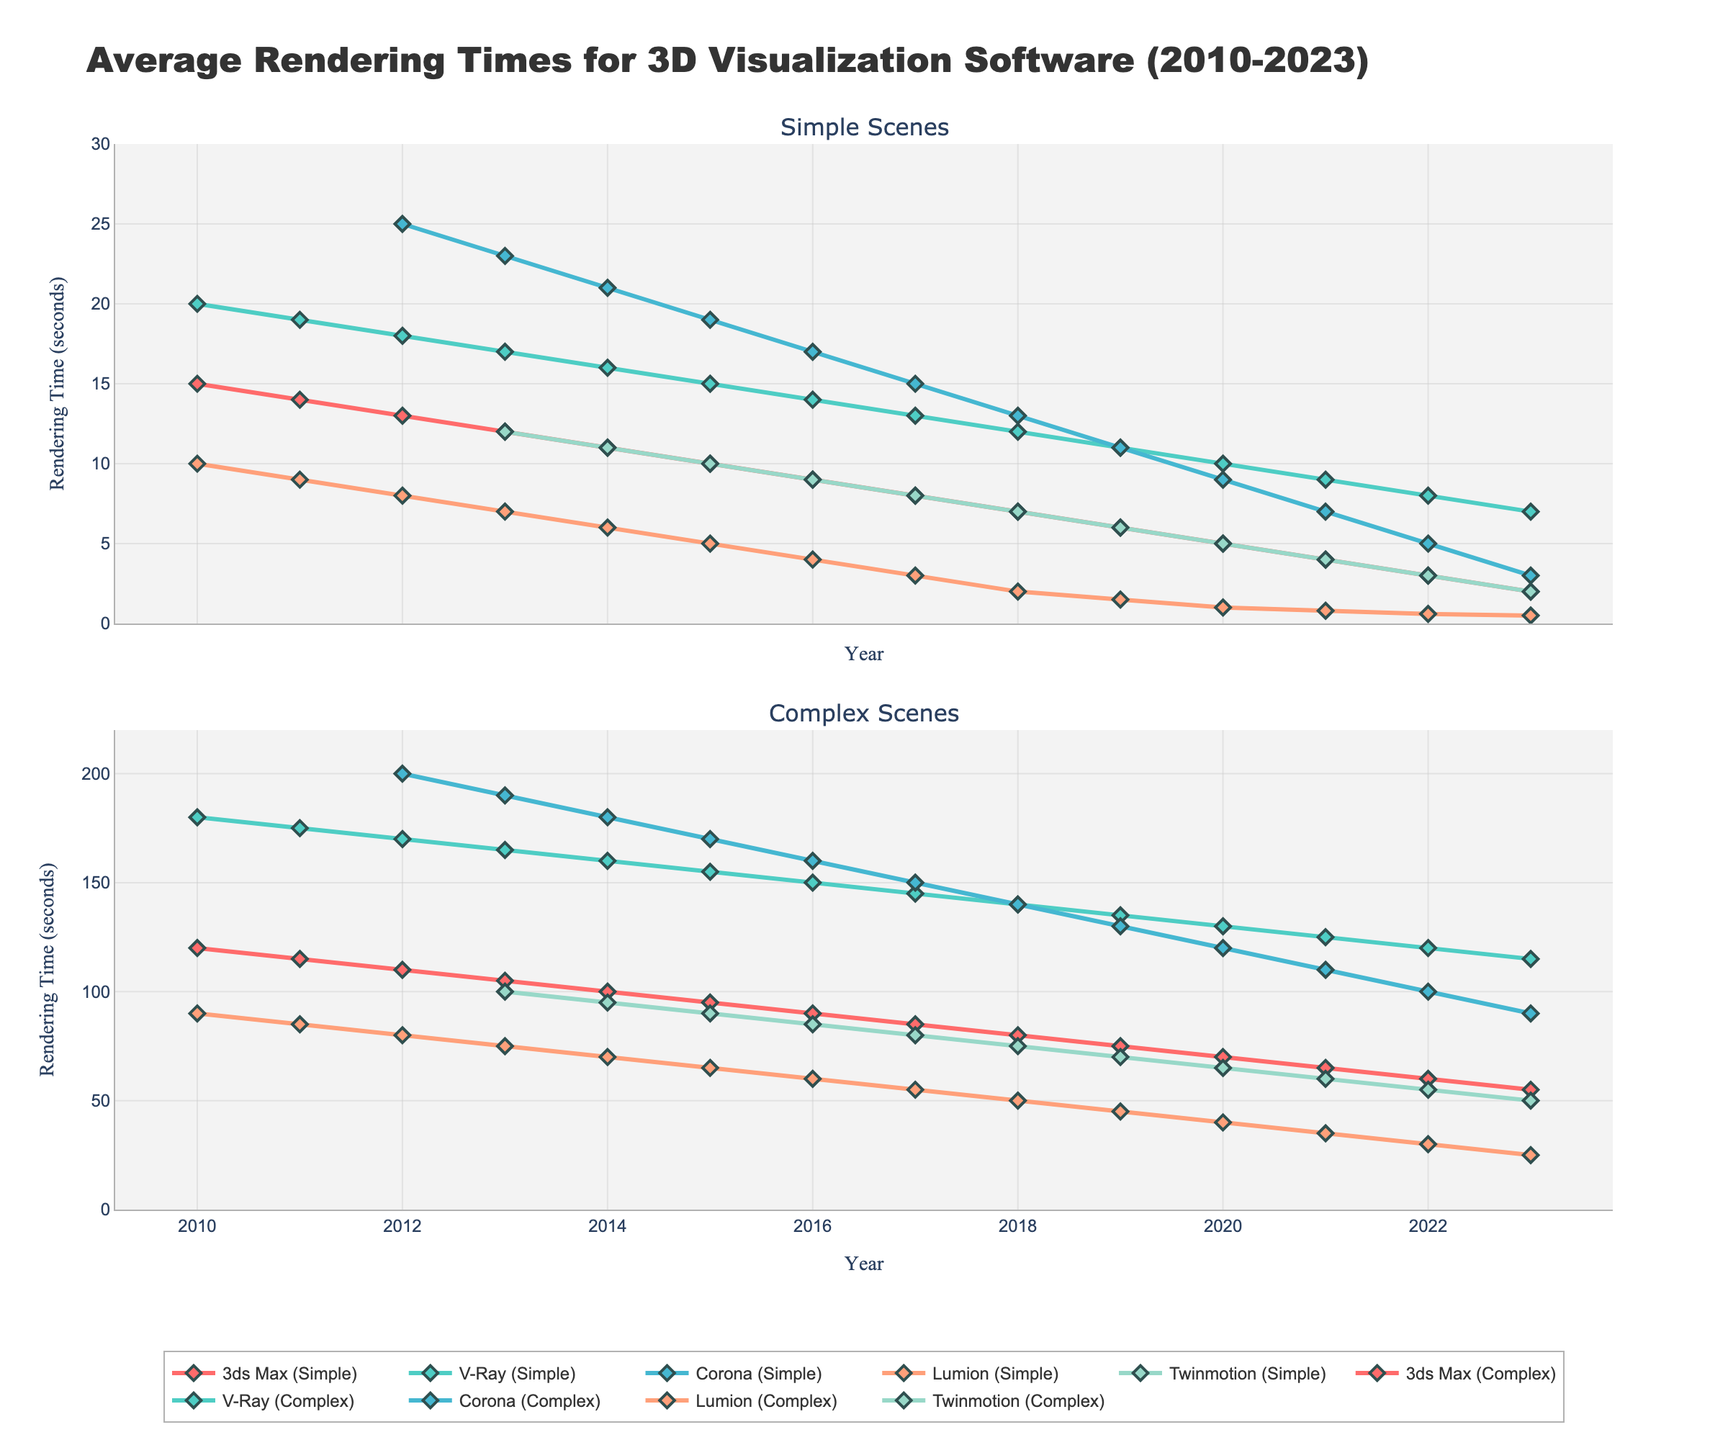Which software had the fastest rendering time for simple scenes in 2023? First, observe the line corresponding to the "Simple Scenes" subplot for 2023. Identify which software line reaches the lowest point on the y-axis. The "Twinmotion (Simple)" line reaches the lowest value at 2 seconds in 2023.
Answer: Twinmotion How has the rendering time of V-Ray for complex scenes changed from 2010 to 2023? Track the line labeled "V-Ray (Complex)" from 2010 to 2023 in the "Complex Scenes" subplot. The rendering time decreased from 180 seconds in 2010 to 115 seconds in 2023, showing a consistent downward trend.
Answer: Decreased by 65 seconds Which software showed the most improvement in rendering time for simple scenes between 2013 and 2018? Compare the time differences for each software in the "Simple Scenes" subplot between 2013 and 2018. Compute the decrease for each line. "Lumion (Simple)" decreased from 7 seconds to 2 seconds, showing an improvement of 5 seconds, which is the most significant.
Answer: Lumion What was the difference in rendering time between 3ds Max (Simple) and Corona (Complex) in 2020? Find the points for 3ds Max (Simple) and Corona (Complex) on the y-axis for the year 2020. 3ds Max (Simple) is at 5 seconds, and Corona (Complex) is at 120 seconds. Subtract the lower value from the higher value: 120 - 5.
Answer: 115 seconds For which complexity (simple or complex) do all software show a greater decrease in rendering time over the given years? Compare the trend lines in both subplots for all software from 2010 to 2023. In the "Complex Scenes" subplot, the initial and final values are generally higher and show a significant decrease. For example, "3ds Max (Complex)" dropped from 120 to 55 seconds. The "Simple Scenes" also show a decrease, but the range is smaller, indicating a more substantial relative improvement for complex scenes.
Answer: Complex How did Lumion's rendering time for complex scenes change from 2010 to 2016? In the "Complex Scenes" subplot, find Lumion's line from 2010 to 2016. It begins at 90 seconds in 2010 and decreases to 60 seconds in 2016, showing a steady decline. Compute the drop: 90 - 60.
Answer: Decreased by 30 seconds Which year saw the most significant decrease in rendering time for Twinmotion (Complex) compared to the previous year? Find the "Twinmotion (Complex)" line on the "Complex Scenes" subplot and calculate year-by-year differences. The most significant drop appears between 2012 and 2013, decreasing from 100 seconds to 95 seconds.
Answer: 2013 What's the average rendering time for Corona (Simple) over the entire period? Locate the Corona (Simple) line in the "Simple Scenes" subplot. Sum the rendering times for each year and divide by the number of years data is available: (23 + 21 + 19 + 17 + 15 + 13 + 11 + 9 + 7 + 5 + 3) across 11 years. Sum is 153; average is 153/11.
Answer: 13.9 seconds Which software exhibited the least variation in rendering time for complex scenes from 2010 to 2023? Examine the span from highest to lowest points in each line in the "Complex Scenes" subplot. "Regression and analysis" show that "3ds Max (Complex)" fluctuated between 120 to 55 seconds. Use standard deviation or range as a measure. "Twinmotion (Complex)" varies from 100 seconds to 50, indicating the least variation.
Answer: Twinmotion 